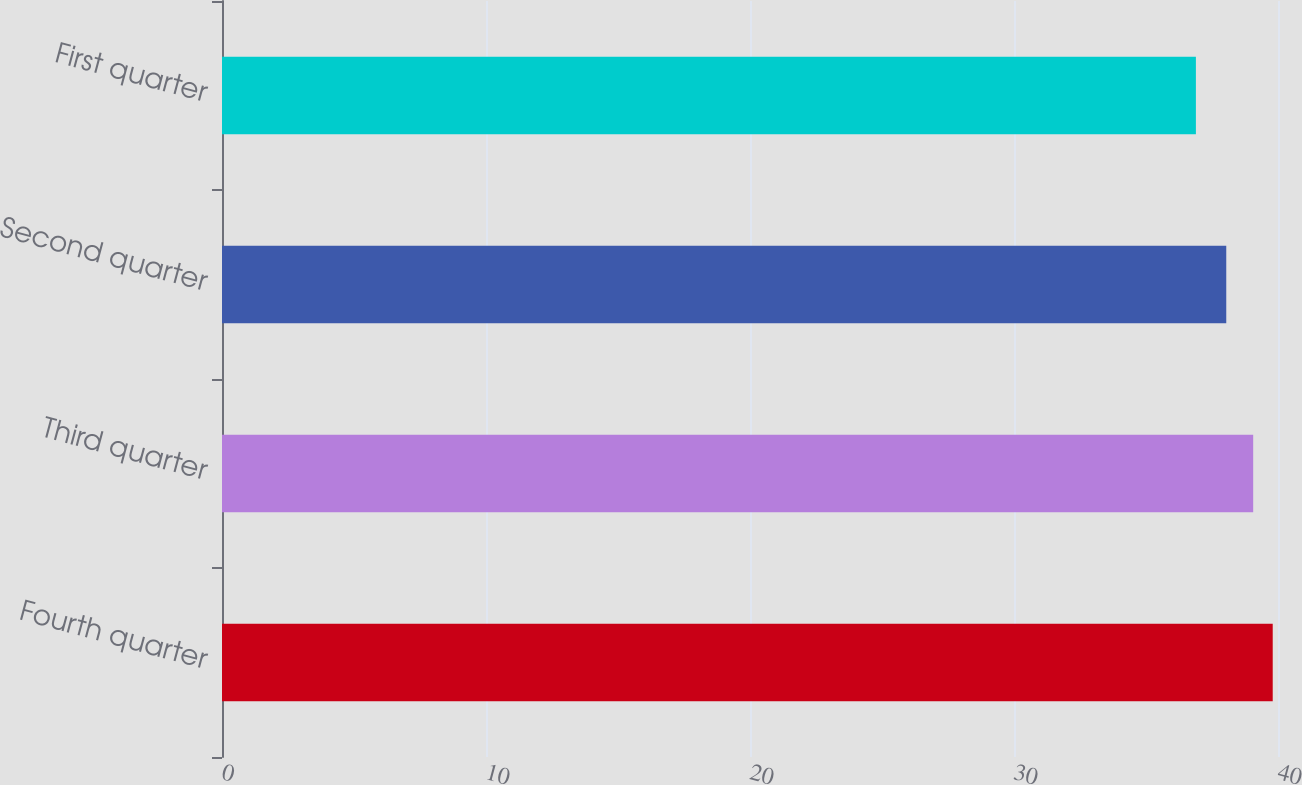Convert chart. <chart><loc_0><loc_0><loc_500><loc_500><bar_chart><fcel>Fourth quarter<fcel>Third quarter<fcel>Second quarter<fcel>First quarter<nl><fcel>39.8<fcel>39.06<fcel>38.04<fcel>36.89<nl></chart> 